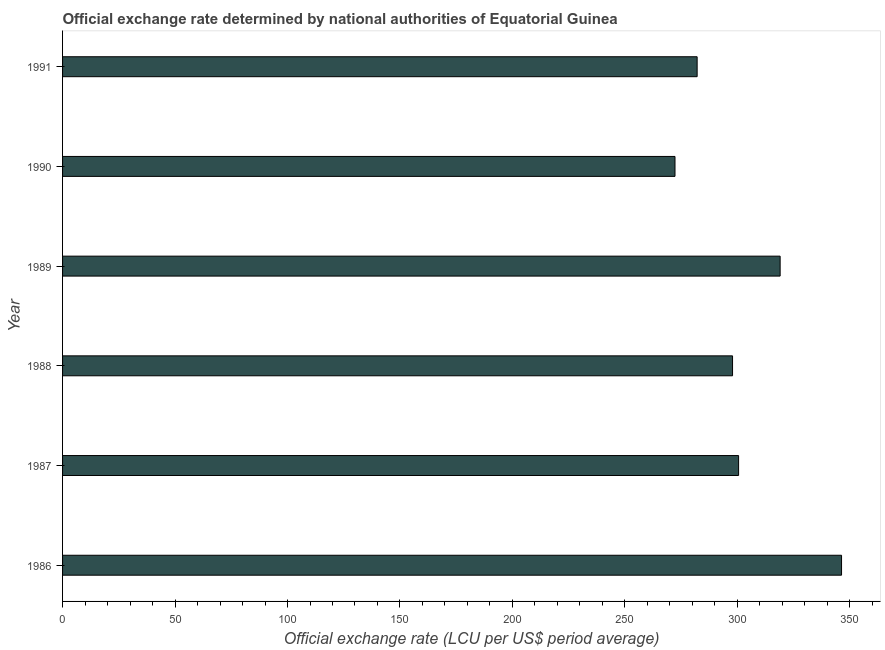Does the graph contain grids?
Give a very brief answer. No. What is the title of the graph?
Offer a very short reply. Official exchange rate determined by national authorities of Equatorial Guinea. What is the label or title of the X-axis?
Offer a very short reply. Official exchange rate (LCU per US$ period average). What is the label or title of the Y-axis?
Provide a short and direct response. Year. What is the official exchange rate in 1987?
Provide a short and direct response. 300.54. Across all years, what is the maximum official exchange rate?
Provide a short and direct response. 346.31. Across all years, what is the minimum official exchange rate?
Make the answer very short. 272.26. What is the sum of the official exchange rate?
Provide a short and direct response. 1818.07. What is the difference between the official exchange rate in 1986 and 1991?
Ensure brevity in your answer.  64.2. What is the average official exchange rate per year?
Keep it short and to the point. 303.01. What is the median official exchange rate?
Your answer should be very brief. 299.19. In how many years, is the official exchange rate greater than 30 ?
Give a very brief answer. 6. Do a majority of the years between 1991 and 1990 (inclusive) have official exchange rate greater than 260 ?
Make the answer very short. No. What is the ratio of the official exchange rate in 1986 to that in 1989?
Your response must be concise. 1.09. Is the official exchange rate in 1989 less than that in 1990?
Provide a short and direct response. No. What is the difference between the highest and the second highest official exchange rate?
Your response must be concise. 27.3. Is the sum of the official exchange rate in 1986 and 1990 greater than the maximum official exchange rate across all years?
Give a very brief answer. Yes. What is the difference between the highest and the lowest official exchange rate?
Provide a short and direct response. 74.04. How many years are there in the graph?
Offer a terse response. 6. What is the difference between two consecutive major ticks on the X-axis?
Your answer should be compact. 50. Are the values on the major ticks of X-axis written in scientific E-notation?
Your response must be concise. No. What is the Official exchange rate (LCU per US$ period average) in 1986?
Your response must be concise. 346.31. What is the Official exchange rate (LCU per US$ period average) of 1987?
Ensure brevity in your answer.  300.54. What is the Official exchange rate (LCU per US$ period average) of 1988?
Your response must be concise. 297.85. What is the Official exchange rate (LCU per US$ period average) in 1989?
Ensure brevity in your answer.  319.01. What is the Official exchange rate (LCU per US$ period average) in 1990?
Make the answer very short. 272.26. What is the Official exchange rate (LCU per US$ period average) of 1991?
Offer a terse response. 282.11. What is the difference between the Official exchange rate (LCU per US$ period average) in 1986 and 1987?
Your response must be concise. 45.77. What is the difference between the Official exchange rate (LCU per US$ period average) in 1986 and 1988?
Your answer should be very brief. 48.46. What is the difference between the Official exchange rate (LCU per US$ period average) in 1986 and 1989?
Your response must be concise. 27.3. What is the difference between the Official exchange rate (LCU per US$ period average) in 1986 and 1990?
Offer a very short reply. 74.04. What is the difference between the Official exchange rate (LCU per US$ period average) in 1986 and 1991?
Your answer should be compact. 64.2. What is the difference between the Official exchange rate (LCU per US$ period average) in 1987 and 1988?
Your answer should be compact. 2.69. What is the difference between the Official exchange rate (LCU per US$ period average) in 1987 and 1989?
Give a very brief answer. -18.47. What is the difference between the Official exchange rate (LCU per US$ period average) in 1987 and 1990?
Give a very brief answer. 28.27. What is the difference between the Official exchange rate (LCU per US$ period average) in 1987 and 1991?
Keep it short and to the point. 18.43. What is the difference between the Official exchange rate (LCU per US$ period average) in 1988 and 1989?
Offer a very short reply. -21.16. What is the difference between the Official exchange rate (LCU per US$ period average) in 1988 and 1990?
Give a very brief answer. 25.58. What is the difference between the Official exchange rate (LCU per US$ period average) in 1988 and 1991?
Keep it short and to the point. 15.74. What is the difference between the Official exchange rate (LCU per US$ period average) in 1989 and 1990?
Give a very brief answer. 46.74. What is the difference between the Official exchange rate (LCU per US$ period average) in 1989 and 1991?
Your response must be concise. 36.9. What is the difference between the Official exchange rate (LCU per US$ period average) in 1990 and 1991?
Offer a terse response. -9.84. What is the ratio of the Official exchange rate (LCU per US$ period average) in 1986 to that in 1987?
Provide a short and direct response. 1.15. What is the ratio of the Official exchange rate (LCU per US$ period average) in 1986 to that in 1988?
Keep it short and to the point. 1.16. What is the ratio of the Official exchange rate (LCU per US$ period average) in 1986 to that in 1989?
Your answer should be very brief. 1.09. What is the ratio of the Official exchange rate (LCU per US$ period average) in 1986 to that in 1990?
Ensure brevity in your answer.  1.27. What is the ratio of the Official exchange rate (LCU per US$ period average) in 1986 to that in 1991?
Your answer should be very brief. 1.23. What is the ratio of the Official exchange rate (LCU per US$ period average) in 1987 to that in 1989?
Your answer should be compact. 0.94. What is the ratio of the Official exchange rate (LCU per US$ period average) in 1987 to that in 1990?
Keep it short and to the point. 1.1. What is the ratio of the Official exchange rate (LCU per US$ period average) in 1987 to that in 1991?
Your response must be concise. 1.06. What is the ratio of the Official exchange rate (LCU per US$ period average) in 1988 to that in 1989?
Offer a terse response. 0.93. What is the ratio of the Official exchange rate (LCU per US$ period average) in 1988 to that in 1990?
Your answer should be very brief. 1.09. What is the ratio of the Official exchange rate (LCU per US$ period average) in 1988 to that in 1991?
Provide a succinct answer. 1.06. What is the ratio of the Official exchange rate (LCU per US$ period average) in 1989 to that in 1990?
Offer a very short reply. 1.17. What is the ratio of the Official exchange rate (LCU per US$ period average) in 1989 to that in 1991?
Make the answer very short. 1.13. What is the ratio of the Official exchange rate (LCU per US$ period average) in 1990 to that in 1991?
Keep it short and to the point. 0.96. 